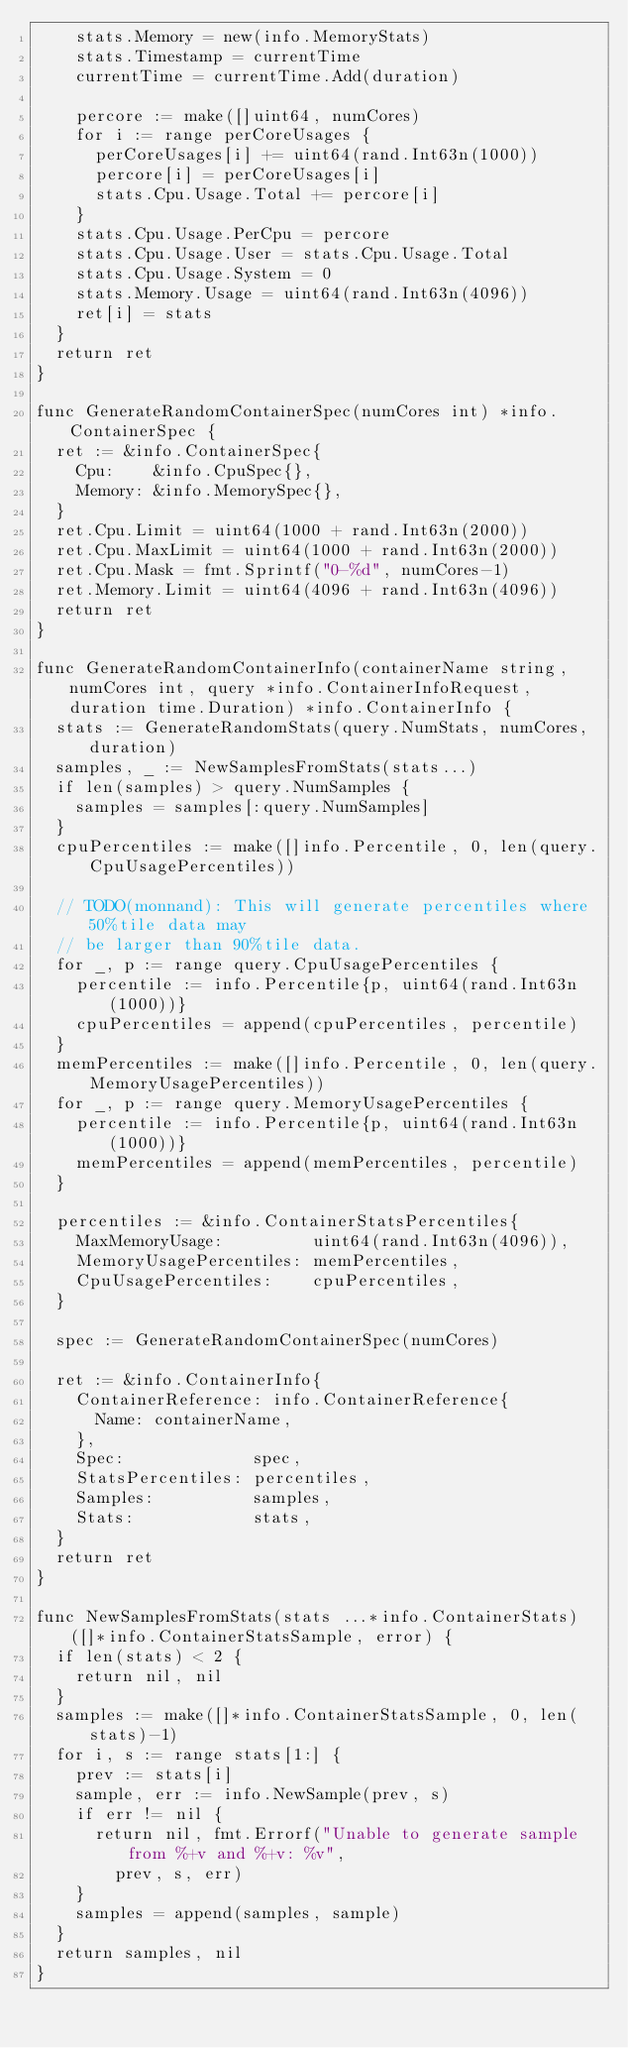Convert code to text. <code><loc_0><loc_0><loc_500><loc_500><_Go_>		stats.Memory = new(info.MemoryStats)
		stats.Timestamp = currentTime
		currentTime = currentTime.Add(duration)

		percore := make([]uint64, numCores)
		for i := range perCoreUsages {
			perCoreUsages[i] += uint64(rand.Int63n(1000))
			percore[i] = perCoreUsages[i]
			stats.Cpu.Usage.Total += percore[i]
		}
		stats.Cpu.Usage.PerCpu = percore
		stats.Cpu.Usage.User = stats.Cpu.Usage.Total
		stats.Cpu.Usage.System = 0
		stats.Memory.Usage = uint64(rand.Int63n(4096))
		ret[i] = stats
	}
	return ret
}

func GenerateRandomContainerSpec(numCores int) *info.ContainerSpec {
	ret := &info.ContainerSpec{
		Cpu:    &info.CpuSpec{},
		Memory: &info.MemorySpec{},
	}
	ret.Cpu.Limit = uint64(1000 + rand.Int63n(2000))
	ret.Cpu.MaxLimit = uint64(1000 + rand.Int63n(2000))
	ret.Cpu.Mask = fmt.Sprintf("0-%d", numCores-1)
	ret.Memory.Limit = uint64(4096 + rand.Int63n(4096))
	return ret
}

func GenerateRandomContainerInfo(containerName string, numCores int, query *info.ContainerInfoRequest, duration time.Duration) *info.ContainerInfo {
	stats := GenerateRandomStats(query.NumStats, numCores, duration)
	samples, _ := NewSamplesFromStats(stats...)
	if len(samples) > query.NumSamples {
		samples = samples[:query.NumSamples]
	}
	cpuPercentiles := make([]info.Percentile, 0, len(query.CpuUsagePercentiles))

	// TODO(monnand): This will generate percentiles where 50%tile data may
	// be larger than 90%tile data.
	for _, p := range query.CpuUsagePercentiles {
		percentile := info.Percentile{p, uint64(rand.Int63n(1000))}
		cpuPercentiles = append(cpuPercentiles, percentile)
	}
	memPercentiles := make([]info.Percentile, 0, len(query.MemoryUsagePercentiles))
	for _, p := range query.MemoryUsagePercentiles {
		percentile := info.Percentile{p, uint64(rand.Int63n(1000))}
		memPercentiles = append(memPercentiles, percentile)
	}

	percentiles := &info.ContainerStatsPercentiles{
		MaxMemoryUsage:         uint64(rand.Int63n(4096)),
		MemoryUsagePercentiles: memPercentiles,
		CpuUsagePercentiles:    cpuPercentiles,
	}

	spec := GenerateRandomContainerSpec(numCores)

	ret := &info.ContainerInfo{
		ContainerReference: info.ContainerReference{
			Name: containerName,
		},
		Spec:             spec,
		StatsPercentiles: percentiles,
		Samples:          samples,
		Stats:            stats,
	}
	return ret
}

func NewSamplesFromStats(stats ...*info.ContainerStats) ([]*info.ContainerStatsSample, error) {
	if len(stats) < 2 {
		return nil, nil
	}
	samples := make([]*info.ContainerStatsSample, 0, len(stats)-1)
	for i, s := range stats[1:] {
		prev := stats[i]
		sample, err := info.NewSample(prev, s)
		if err != nil {
			return nil, fmt.Errorf("Unable to generate sample from %+v and %+v: %v",
				prev, s, err)
		}
		samples = append(samples, sample)
	}
	return samples, nil
}
</code> 